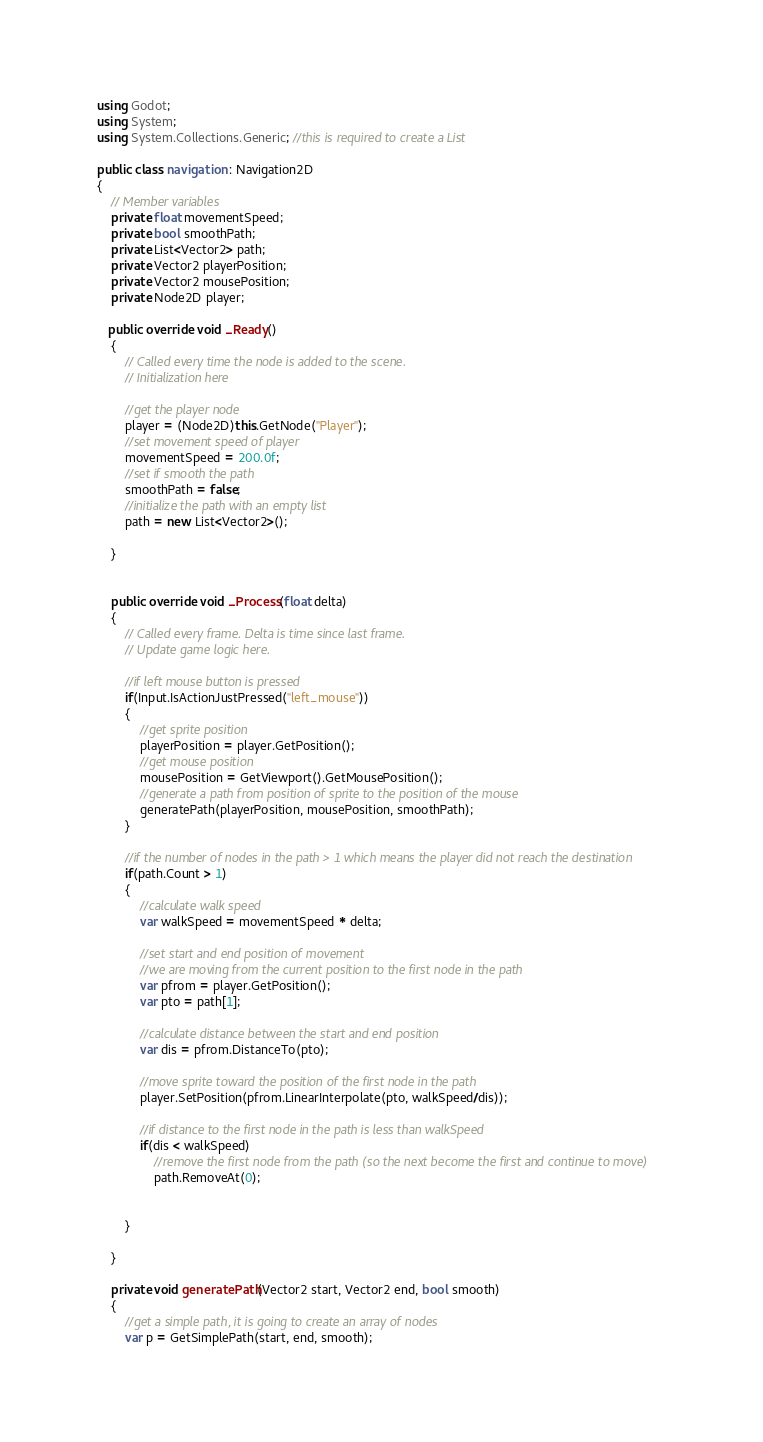<code> <loc_0><loc_0><loc_500><loc_500><_C#_>using Godot;
using System;
using System.Collections.Generic; //this is required to create a List

public class navigation : Navigation2D
{
    // Member variables
	private float movementSpeed;
	private bool smoothPath;
	private List<Vector2> path;
	private Vector2 playerPosition;
	private Vector2 mousePosition; 
	private Node2D player;

   public override void _Ready()
    {
        // Called every time the node is added to the scene.
        // Initialization here
		
		//get the player node
		player = (Node2D)this.GetNode("Player");
		//set movement speed of player
		movementSpeed = 200.0f;
		//set if smooth the path
		smoothPath = false;
		//initialize the path with an empty list
		path = new List<Vector2>();
        
    }
	

    public override void _Process(float delta)
    {
        // Called every frame. Delta is time since last frame.
        // Update game logic here.
		
		//if left mouse button is pressed
		if(Input.IsActionJustPressed("left_mouse"))
		{
			//get sprite position
			playerPosition = player.GetPosition();
			//get mouse position
			mousePosition = GetViewport().GetMousePosition();
			//generate a path from position of sprite to the position of the mouse
			generatePath(playerPosition, mousePosition, smoothPath);
		}
		
		//if the number of nodes in the path > 1 which means the player did not reach the destination
		if(path.Count > 1)
		{
			//calculate walk speed
			var walkSpeed = movementSpeed * delta;
			
			//set start and end position of movement
			//we are moving from the current position to the first node in the path
			var pfrom = player.GetPosition();
			var pto = path[1];
			
			//calculate distance between the start and end position
			var dis = pfrom.DistanceTo(pto);
			
			//move sprite toward the position of the first node in the path
			player.SetPosition(pfrom.LinearInterpolate(pto, walkSpeed/dis));
			
			//if distance to the first node in the path is less than walkSpeed
			if(dis < walkSpeed)
				//remove the first node from the path (so the next become the first and continue to move)
				path.RemoveAt(0);
			
			
		}
        
    }
	
	private void generatePath(Vector2 start, Vector2 end, bool smooth)
	{
		//get a simple path, it is going to create an array of nodes
		var p = GetSimplePath(start, end, smooth);</code> 